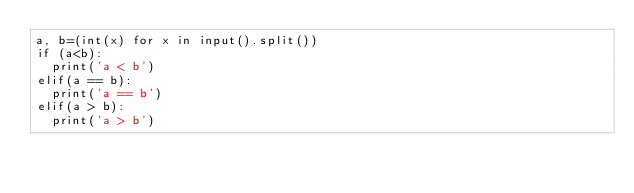Convert code to text. <code><loc_0><loc_0><loc_500><loc_500><_Python_>a, b=(int(x) for x in input().split())
if (a<b):
  print('a < b')
elif(a == b):
  print('a == b')
elif(a > b):
  print('a > b')
</code> 